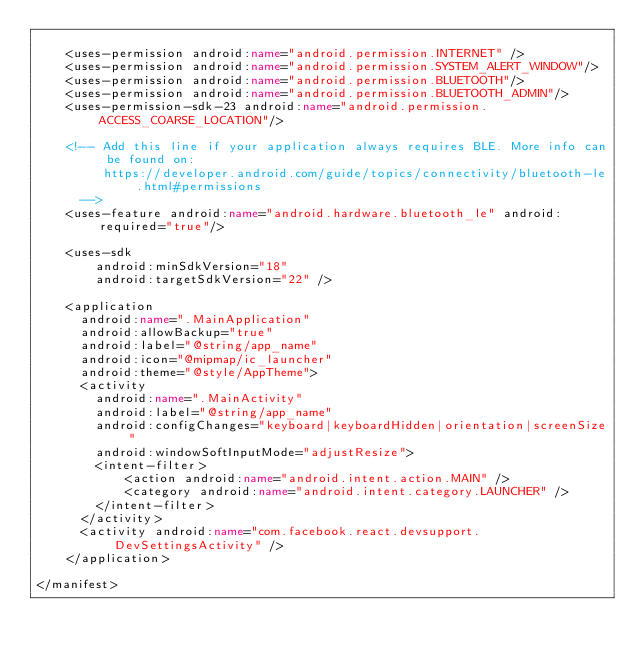Convert code to text. <code><loc_0><loc_0><loc_500><loc_500><_XML_>
    <uses-permission android:name="android.permission.INTERNET" />
    <uses-permission android:name="android.permission.SYSTEM_ALERT_WINDOW"/>
    <uses-permission android:name="android.permission.BLUETOOTH"/>
    <uses-permission android:name="android.permission.BLUETOOTH_ADMIN"/>
    <uses-permission-sdk-23 android:name="android.permission.ACCESS_COARSE_LOCATION"/>

    <!-- Add this line if your application always requires BLE. More info can be found on:
         https://developer.android.com/guide/topics/connectivity/bluetooth-le.html#permissions
      -->
    <uses-feature android:name="android.hardware.bluetooth_le" android:required="true"/>

    <uses-sdk
        android:minSdkVersion="18"
        android:targetSdkVersion="22" />

    <application
      android:name=".MainApplication"
      android:allowBackup="true"
      android:label="@string/app_name"
      android:icon="@mipmap/ic_launcher"
      android:theme="@style/AppTheme">
      <activity
        android:name=".MainActivity"
        android:label="@string/app_name"
        android:configChanges="keyboard|keyboardHidden|orientation|screenSize"
        android:windowSoftInputMode="adjustResize">
        <intent-filter>
            <action android:name="android.intent.action.MAIN" />
            <category android:name="android.intent.category.LAUNCHER" />
        </intent-filter>
      </activity>
      <activity android:name="com.facebook.react.devsupport.DevSettingsActivity" />
    </application>

</manifest>
</code> 